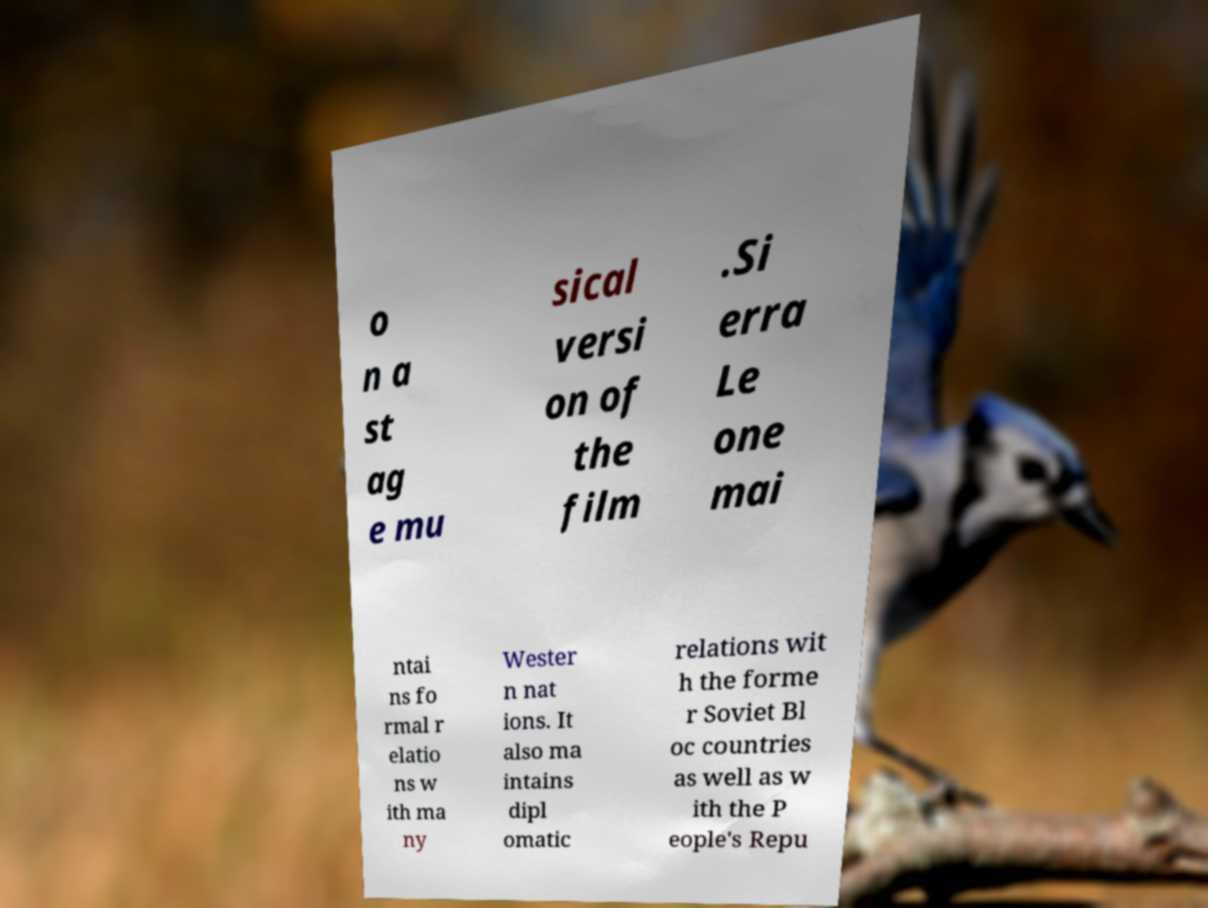Please identify and transcribe the text found in this image. o n a st ag e mu sical versi on of the film .Si erra Le one mai ntai ns fo rmal r elatio ns w ith ma ny Wester n nat ions. It also ma intains dipl omatic relations wit h the forme r Soviet Bl oc countries as well as w ith the P eople's Repu 